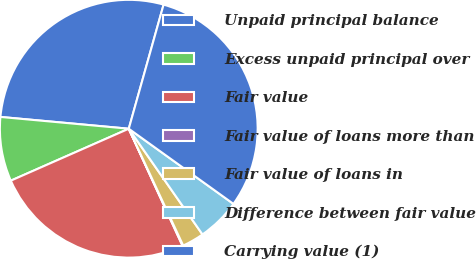Convert chart. <chart><loc_0><loc_0><loc_500><loc_500><pie_chart><fcel>Unpaid principal balance<fcel>Excess unpaid principal over<fcel>Fair value<fcel>Fair value of loans more than<fcel>Fair value of loans in<fcel>Difference between fair value<fcel>Carrying value (1)<nl><fcel>27.9%<fcel>8.06%<fcel>25.25%<fcel>0.09%<fcel>2.75%<fcel>5.4%<fcel>30.56%<nl></chart> 